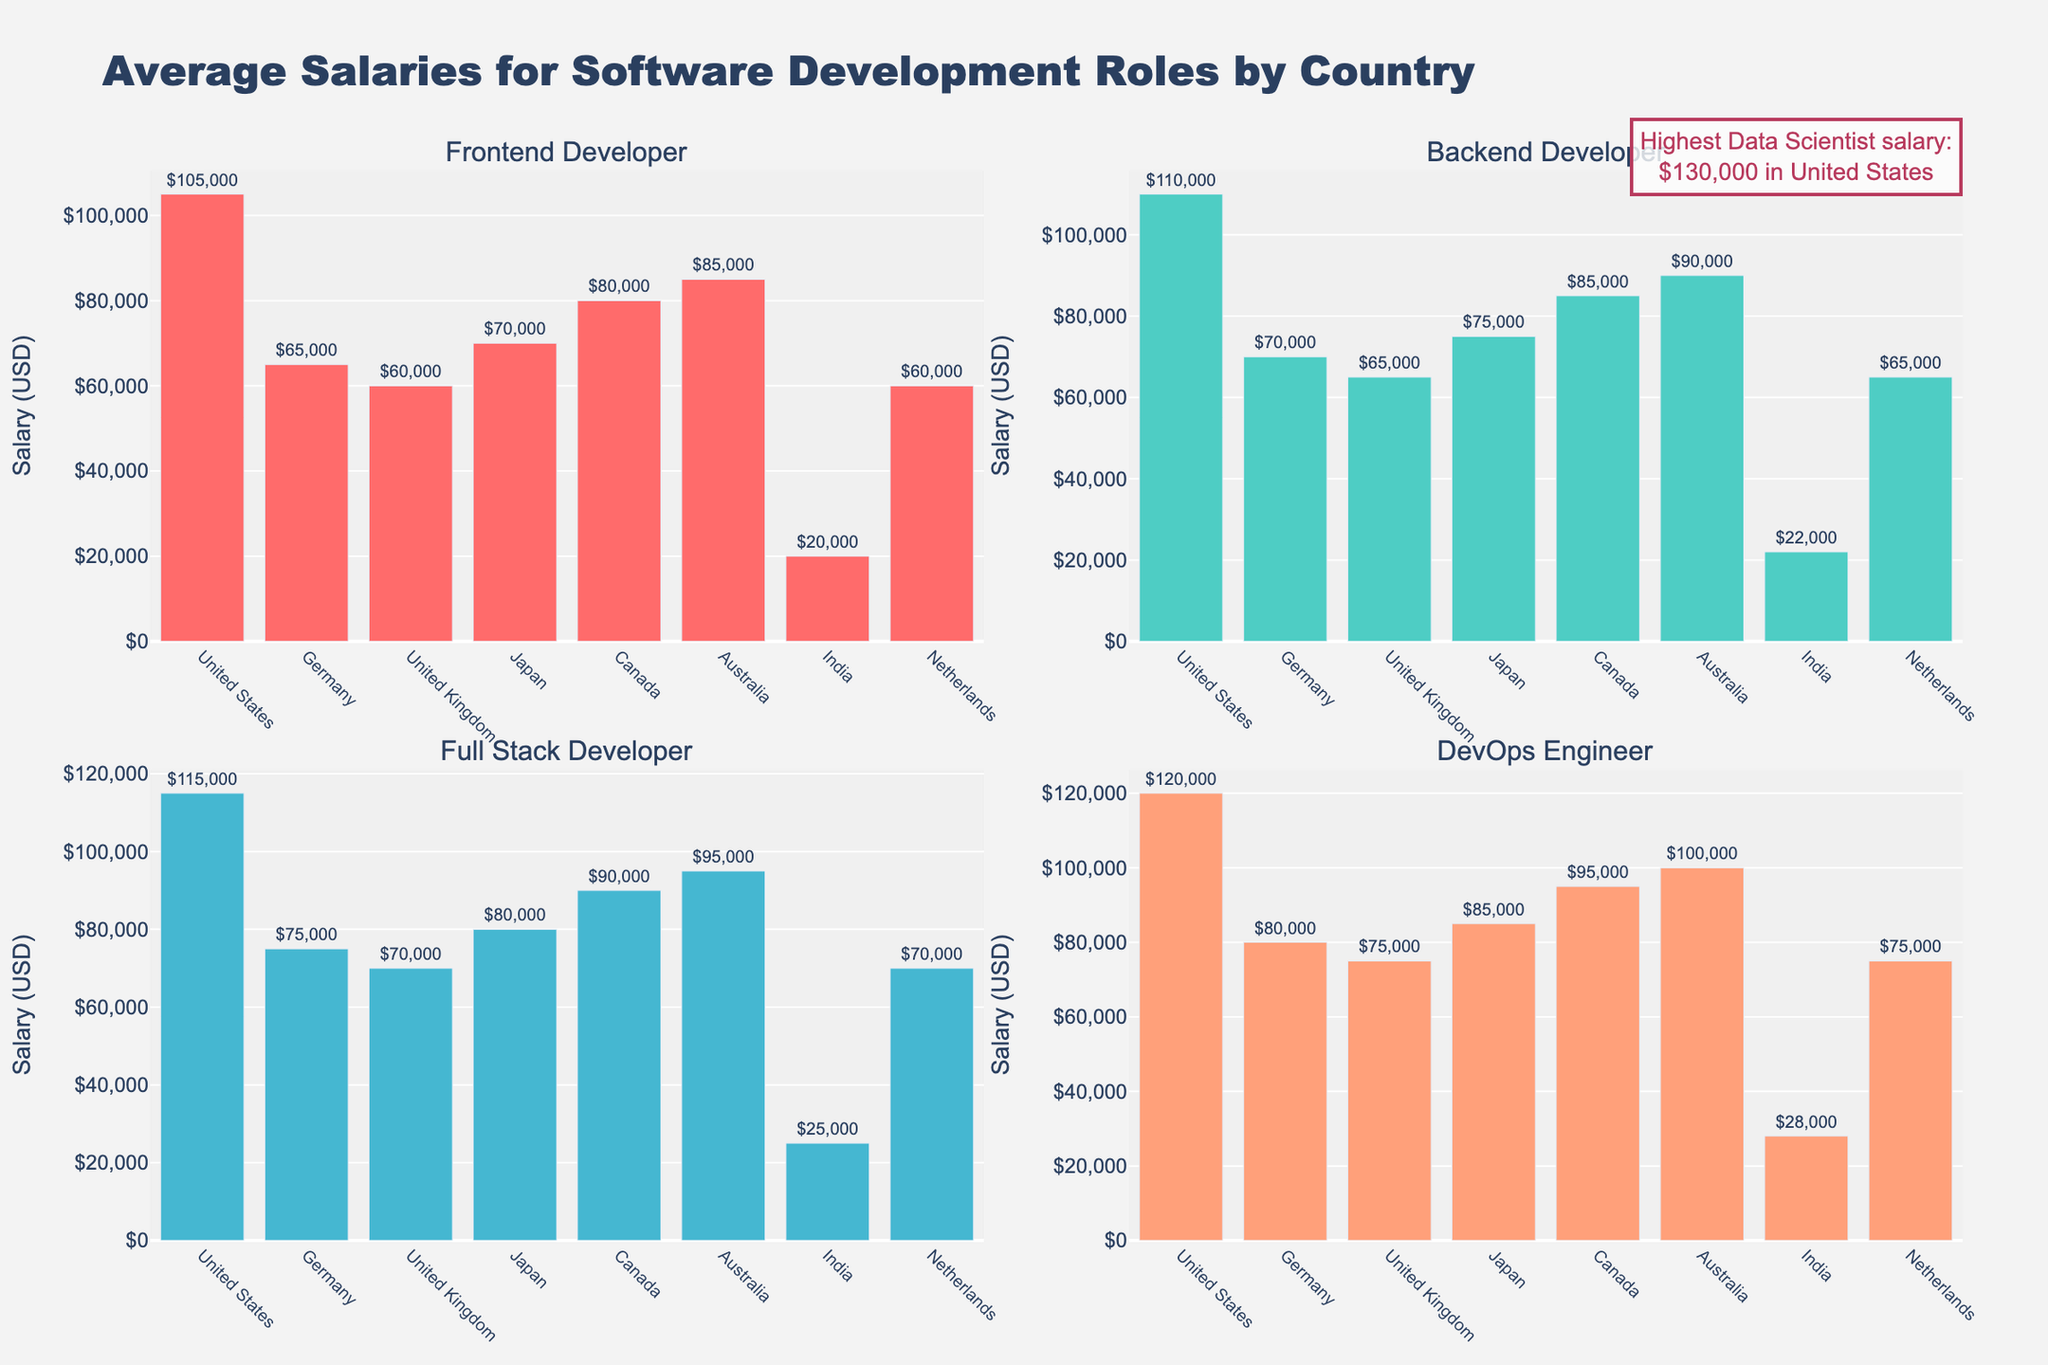What title is given to the figure? The title is prominently displayed at the top of the figure. It reads "Average Salaries for Software Development Roles by Country".
Answer: Average Salaries for Software Development Roles by Country Which country has the highest average salary for a Frontend Developer? In the Frontend Developer subplot, the highest bar corresponds to the United States with a salary of $105,000.
Answer: United States What's the average salary for a Backend Developer in Germany and Japan combined? The Backend Developer subplot shows Germany with a salary of $70,000 and Japan with $75,000. The average is calculated as (70,000 + 75,000) / 2 = 72,500.
Answer: $72,500 How does the average salary for a DevOps Engineer in Canada compare to that in Australia? In the DevOps Engineer subplot, the bar for Canada is at $95,000 while Australia is at $100,000. Canada’s average salary for a DevOps Engineer is $5,000 less than Australia’s.
Answer: $5,000 less Which role is most lucrative in the United Kingdom across all the plotted roles? By comparing the heights of the bars for each role in the UK, the highest is for a DevOps Engineer, which is $75,000.
Answer: DevOps Engineer What is the total average salary for all the software development roles in India? The subplot values for India are $20,000 (Frontend), $22,000 (Backend), $25,000 (Full Stack), and $28,000 (DevOps). Summing these gives 20,000 + 22,000 + 25,000 + 28,000 = 95,000.
Answer: $95,000 Which country offers the highest salary for Backend Developers? The Backend Developer subplot shows the highest bar for the United States at $110,000.
Answer: United States Compare the average salary for a Full Stack Developer in the Netherlands and the United Kingdom. Which one is higher? The Full Stack Developer subplot shows both Netherlands and the United Kingdom at $70,000, hence their salaries are equal.
Answer: Equal What’s the difference in average salary between a Data Scientist and a Frontend Developer in Germany? The average salary for a Data Scientist in Germany is $85,000 and for a Frontend Developer is $65,000. The difference is $85,000 - $65,000 = $20,000.
Answer: $20,000 